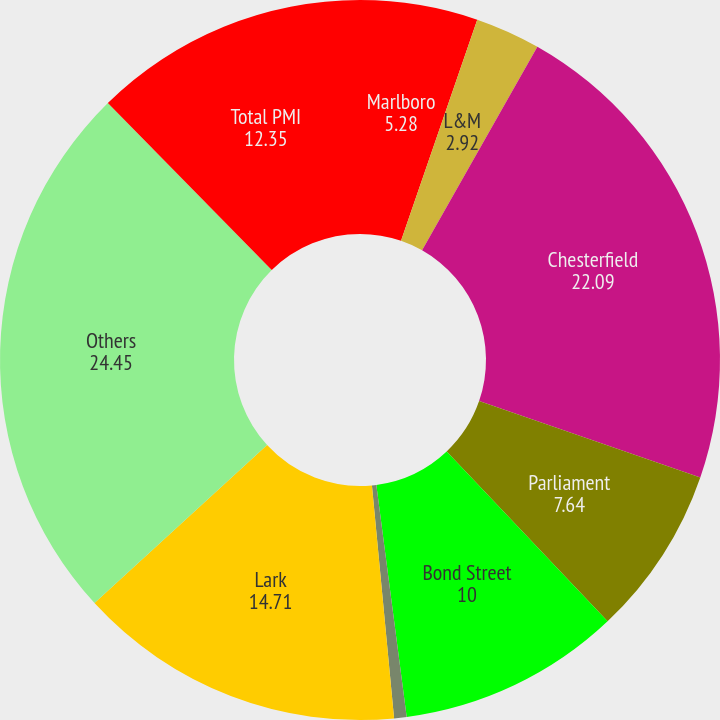Convert chart. <chart><loc_0><loc_0><loc_500><loc_500><pie_chart><fcel>Marlboro<fcel>L&M<fcel>Chesterfield<fcel>Parliament<fcel>Bond Street<fcel>Philip Morris<fcel>Lark<fcel>Others<fcel>Total PMI<nl><fcel>5.28%<fcel>2.92%<fcel>22.09%<fcel>7.64%<fcel>10.0%<fcel>0.56%<fcel>14.71%<fcel>24.45%<fcel>12.35%<nl></chart> 